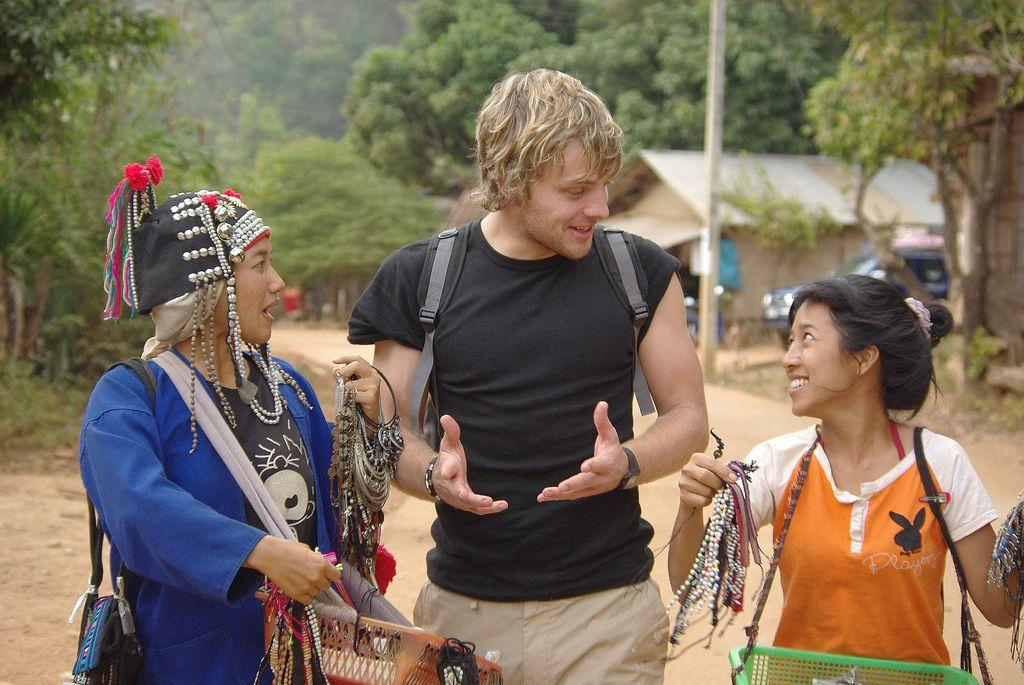How many people are present in the image? There are three persons standing in the image. What are the persons doing in the image? The persons are talking. What can be seen in the background of the image? Trees, poles, vehicles, and houses are visible in the background. What type of lettuce can be seen growing on the mountain in the image? There is no lettuce or mountain present in the image. 